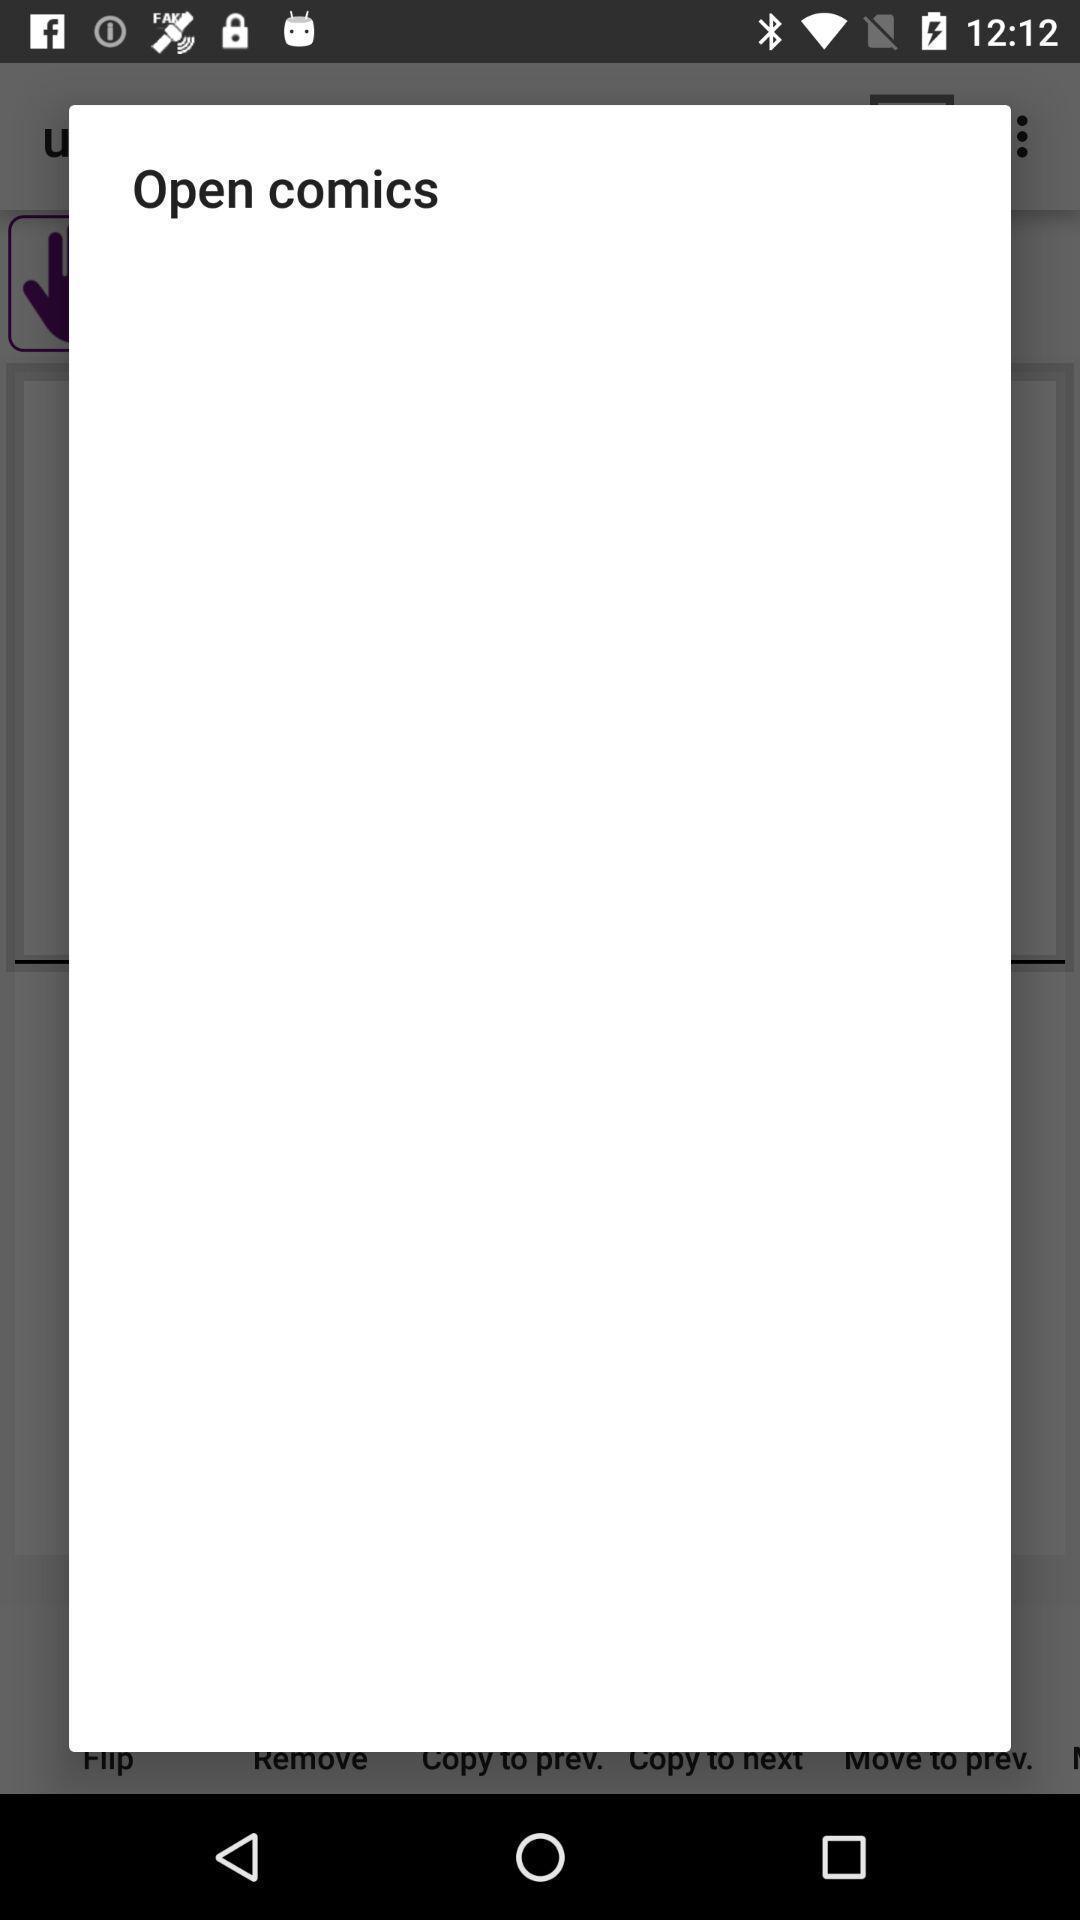Describe the content in this image. Pop-up showing information about application. 